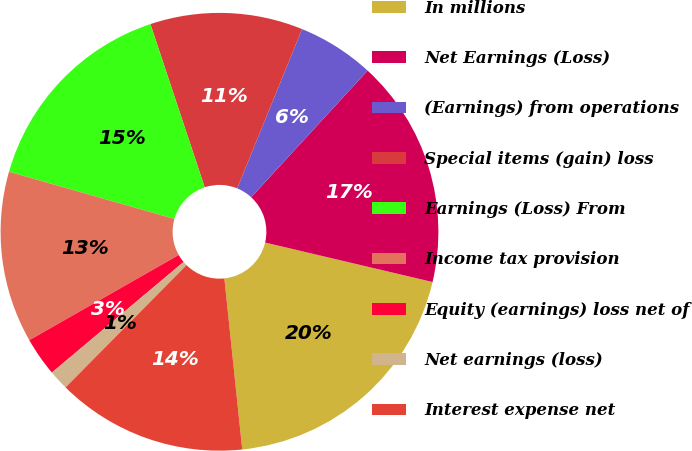<chart> <loc_0><loc_0><loc_500><loc_500><pie_chart><fcel>In millions<fcel>Net Earnings (Loss)<fcel>(Earnings) from operations<fcel>Special items (gain) loss<fcel>Earnings (Loss) From<fcel>Income tax provision<fcel>Equity (earnings) loss net of<fcel>Net earnings (loss)<fcel>Interest expense net<nl><fcel>19.66%<fcel>16.86%<fcel>5.67%<fcel>11.27%<fcel>15.47%<fcel>12.67%<fcel>2.87%<fcel>1.47%<fcel>14.07%<nl></chart> 